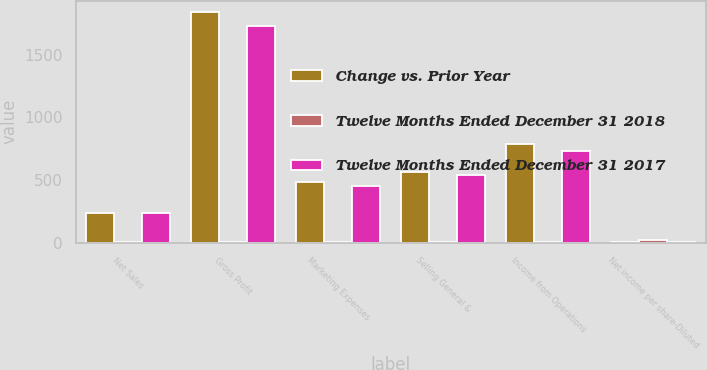Convert chart to OTSL. <chart><loc_0><loc_0><loc_500><loc_500><stacked_bar_chart><ecel><fcel>Net Sales<fcel>Gross Profit<fcel>Marketing Expenses<fcel>Selling General &<fcel>Income from Operations<fcel>Net income per share-Diluted<nl><fcel>Change vs. Prior Year<fcel>237.95<fcel>1840.8<fcel>483.2<fcel>565.9<fcel>791.7<fcel>2.27<nl><fcel>Twelve Months Ended December 31 2018<fcel>9.8<fcel>6.4<fcel>6.4<fcel>4.3<fcel>8.1<fcel>21.7<nl><fcel>Twelve Months Ended December 31 2017<fcel>237.95<fcel>1729.6<fcel>454.2<fcel>542.7<fcel>732.7<fcel>2.9<nl></chart> 